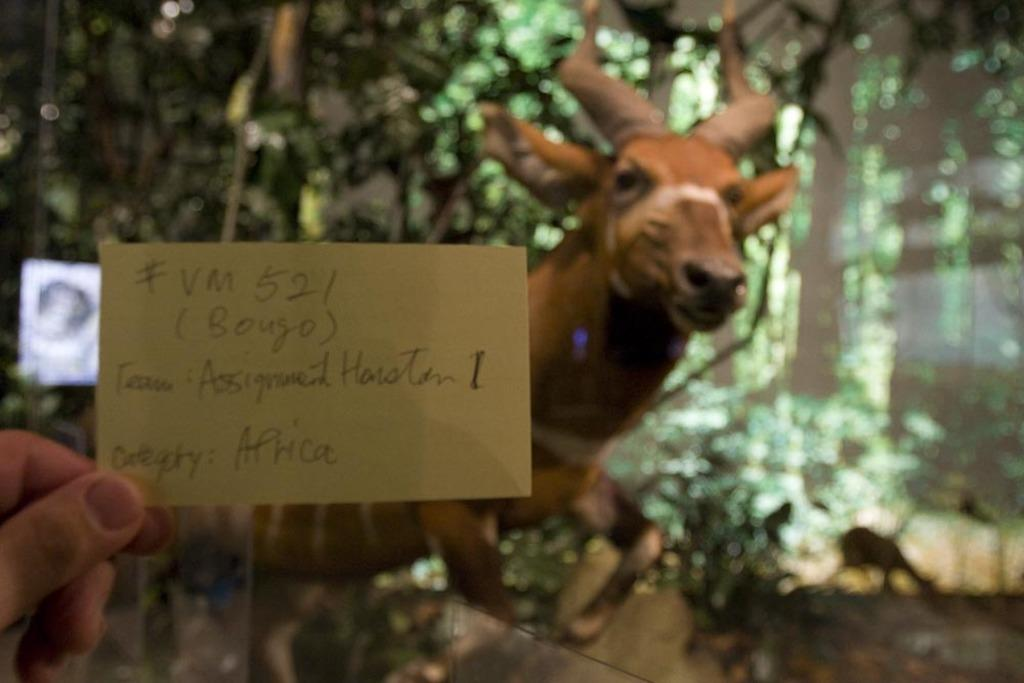What is the person holding in the image? There is a hand holding a card in the image. What can be found on the card? The card contains written text. What type of animal is present in the image? There is an animal in the middle of the image. How many potatoes are visible on the island in the image? There is no island or potatoes present in the image. What thoughts or ideas are being expressed by the animal's mind in the image? The image does not provide any information about the animal's mind or thoughts. 